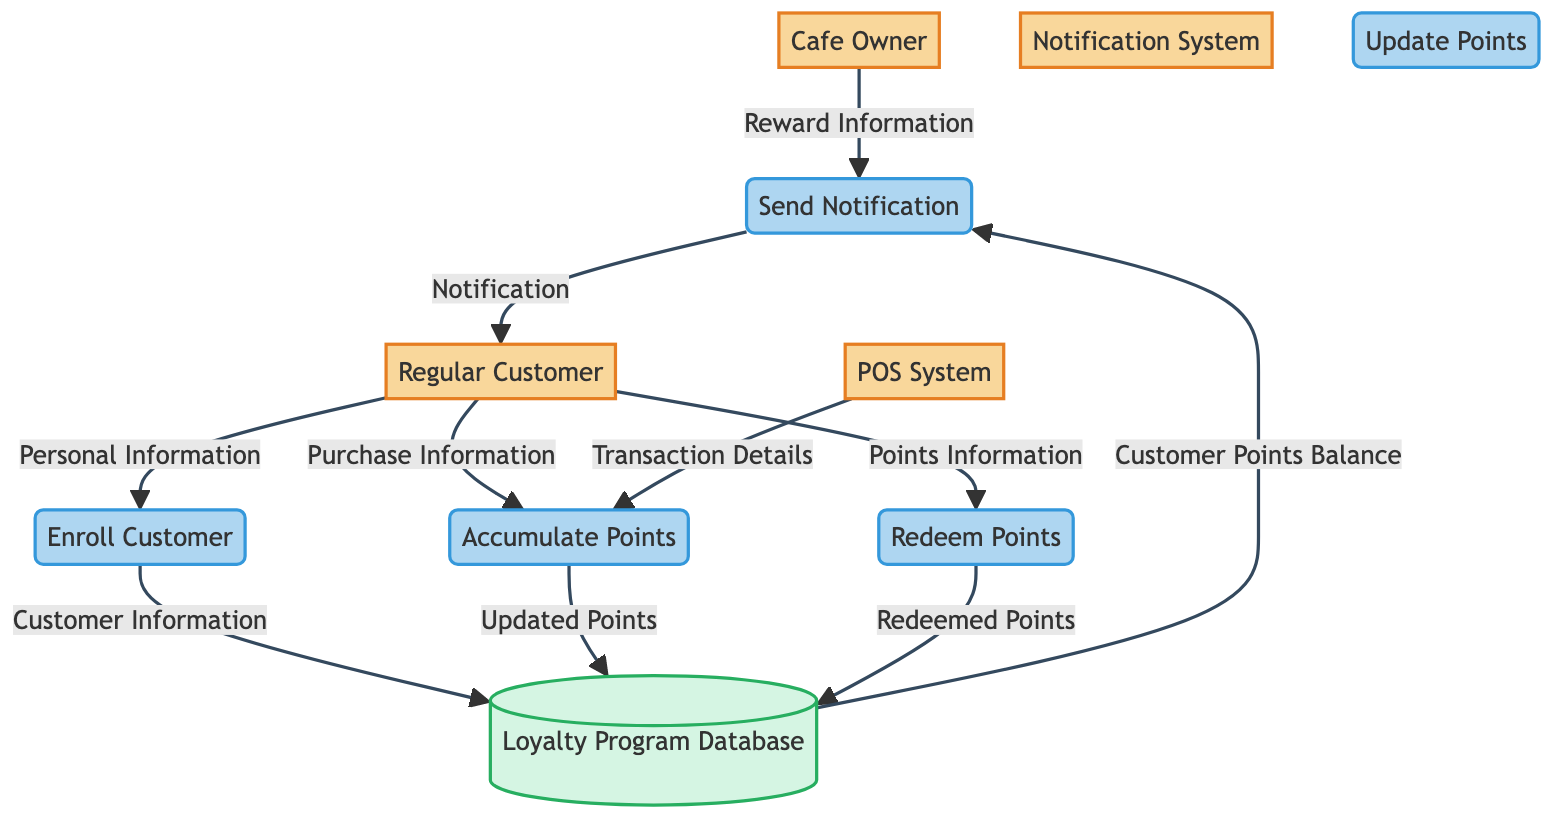What entities are involved in the loyalty program management? The diagram shows five entities: Cafe Owner, Regular Customer, Loyalty Program Database, POS System, and Notification System. Each entity represents a key player or storage system in the loyalty program process.
Answer: Cafe Owner, Regular Customer, Loyalty Program Database, POS System, Notification System How many processes are defined in the diagram? There are five processes shown in the diagram: Enroll Customer, Accumulate Points, Redeem Points, Update Points, and Send Notification. These processes illustrate various actions performed during loyalty program management.
Answer: Five What is the role of the Loyalty Program Database? The Loyalty Program Database stores customer points, rewards, and transactions associated with the loyalty program. It acts as a central repository for all loyalty-related data and updates.
Answer: Store data Which entity sends notifications to Regular Customers? The Notification System is responsible for sending notifications about points and rewards to Regular Customers, as indicated by the flow direction in the diagram.
Answer: Notification System How does a Regular Customer enroll in the loyalty program? A Regular Customer provides Personal Information to the Enroll Customer process, which subsequently adds their data to the Loyalty Program Database as Customer Information.
Answer: Personal Information What data flow occurs when a purchase is made by a Regular Customer? Upon making a purchase, the Regular Customer sends Purchase Information to the Accumulate Points process, which subsequently receives Transaction Details from the POS System. This flow results in updates to the Loyalty Program Database.
Answer: Purchase Information, Transaction Details What happens to customer points after they redeem them? When customers redeem their points, the Redeem Points process updates the Loyalty Program Database with the Redeemed Points, indicating that the points have been used for rewards.
Answer: Updated Points What does the Cafe Owner provide for sending notifications? The Cafe Owner provides Reward Information, which is utilized by the Send Notification process to inform Regular Customers about their rewards and points.
Answer: Reward Information What type of data is sent from the Loyalty Program Database to the Send Notification process? The Loyalty Program Database sends Customer Points Balance to the Send Notification process, which is essential for notifying customers about their current points status.
Answer: Customer Points Balance 